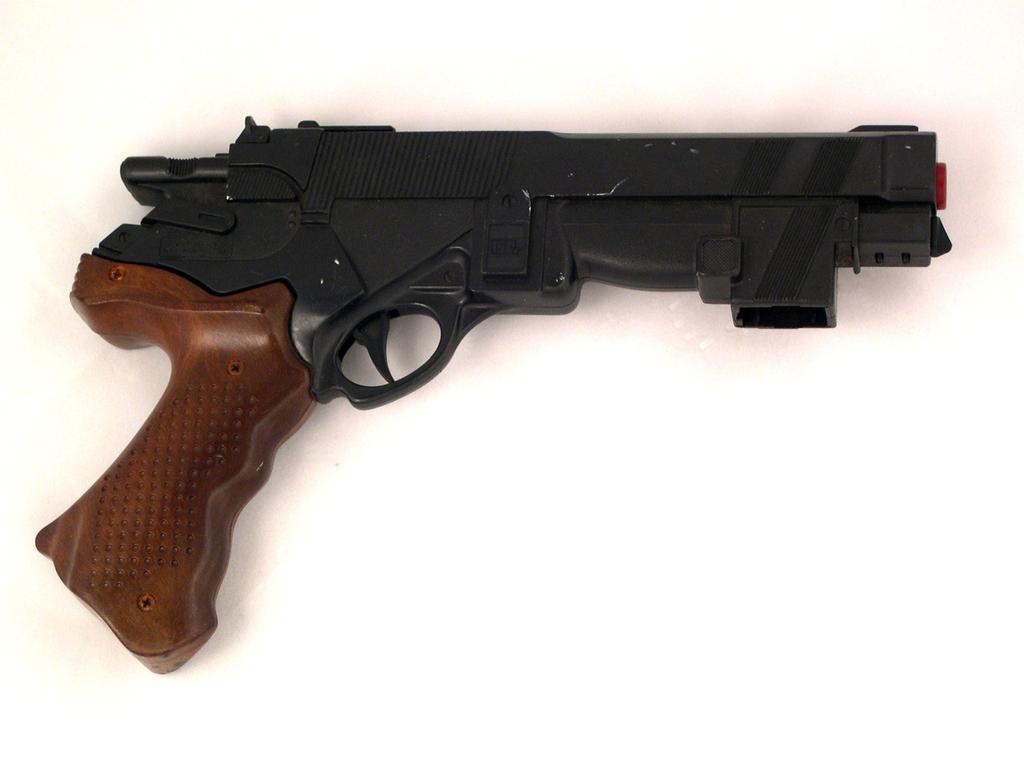In one or two sentences, can you explain what this image depicts? This image consists of a gun which is brown and black in colour. 